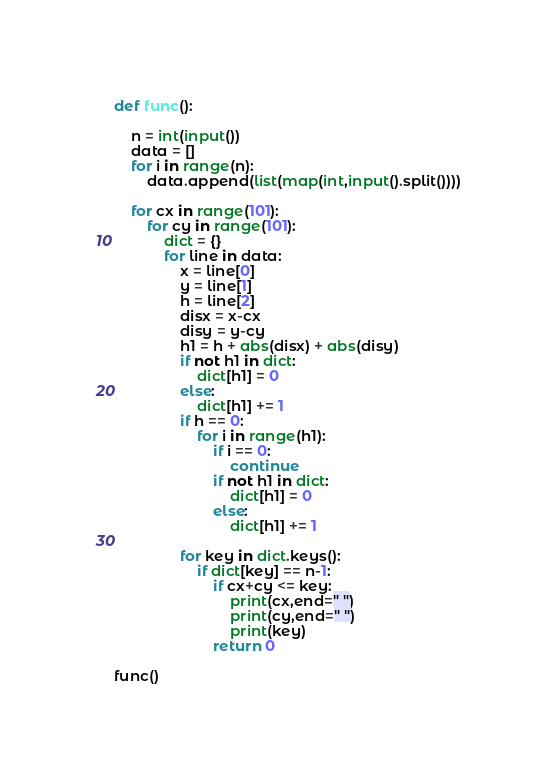Convert code to text. <code><loc_0><loc_0><loc_500><loc_500><_Python_>

def func():

    n = int(input())
    data = []
    for i in range(n):
        data.append(list(map(int,input().split())))

    for cx in range(101):
        for cy in range(101):
            dict = {}
            for line in data:
                x = line[0]
                y = line[1]
                h = line[2]
                disx = x-cx
                disy = y-cy
                h1 = h + abs(disx) + abs(disy)
                if not h1 in dict:
                    dict[h1] = 0
                else:
                    dict[h1] += 1
                if h == 0:
                    for i in range(h1):
                        if i == 0:
                            continue
                        if not h1 in dict:
                            dict[h1] = 0
                        else:
                            dict[h1] += 1

                for key in dict.keys():
                    if dict[key] == n-1:
                        if cx+cy <= key:
                            print(cx,end=" ")
                            print(cy,end=" ")
                            print(key)
                        return 0

func()


</code> 